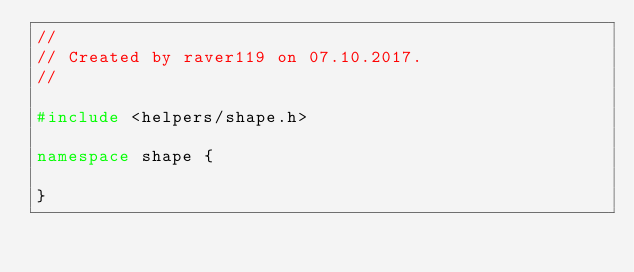Convert code to text. <code><loc_0><loc_0><loc_500><loc_500><_C++_>//
// Created by raver119 on 07.10.2017.
//

#include <helpers/shape.h>

namespace shape {

}

</code> 